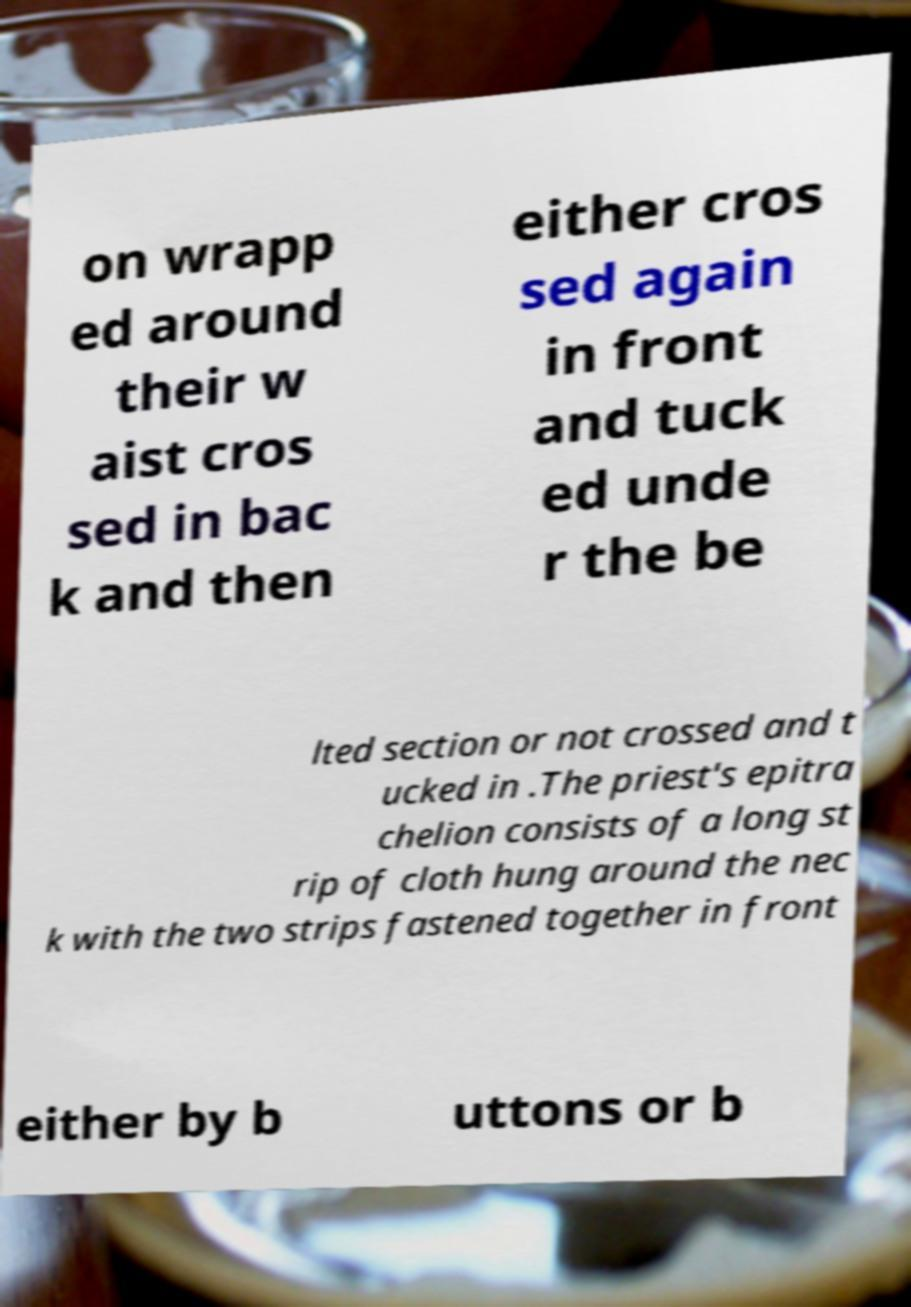Please identify and transcribe the text found in this image. on wrapp ed around their w aist cros sed in bac k and then either cros sed again in front and tuck ed unde r the be lted section or not crossed and t ucked in .The priest's epitra chelion consists of a long st rip of cloth hung around the nec k with the two strips fastened together in front either by b uttons or b 